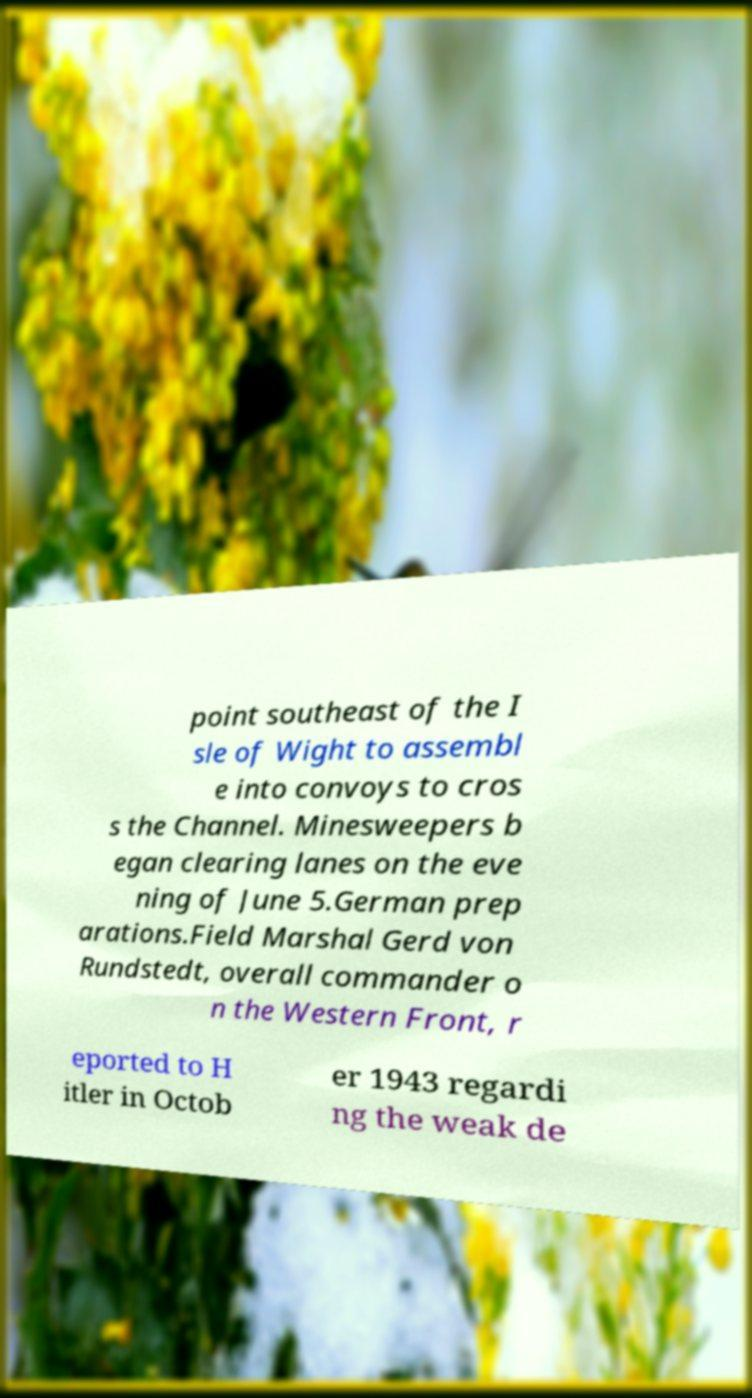Please identify and transcribe the text found in this image. point southeast of the I sle of Wight to assembl e into convoys to cros s the Channel. Minesweepers b egan clearing lanes on the eve ning of June 5.German prep arations.Field Marshal Gerd von Rundstedt, overall commander o n the Western Front, r eported to H itler in Octob er 1943 regardi ng the weak de 